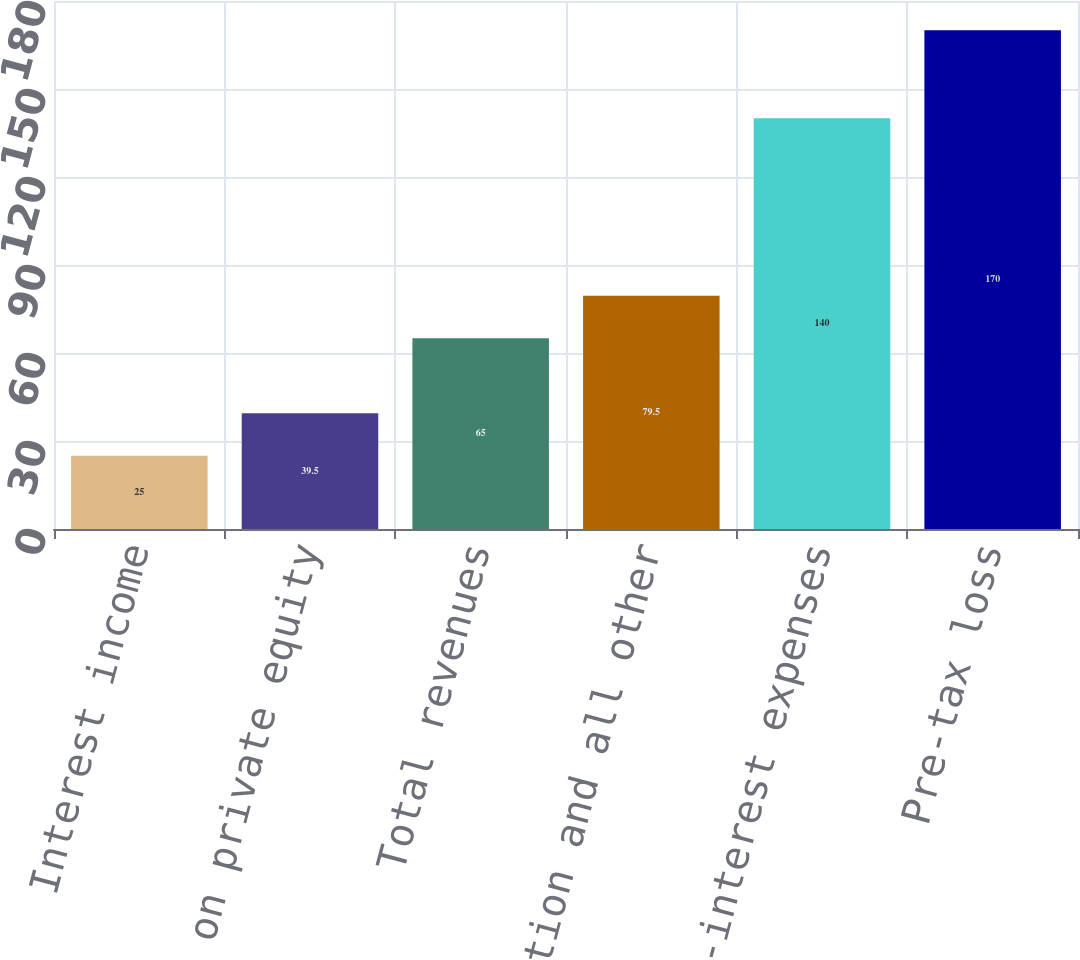<chart> <loc_0><loc_0><loc_500><loc_500><bar_chart><fcel>Interest income<fcel>Gains on private equity<fcel>Total revenues<fcel>Compensation and all other<fcel>Total non-interest expenses<fcel>Pre-tax loss<nl><fcel>25<fcel>39.5<fcel>65<fcel>79.5<fcel>140<fcel>170<nl></chart> 